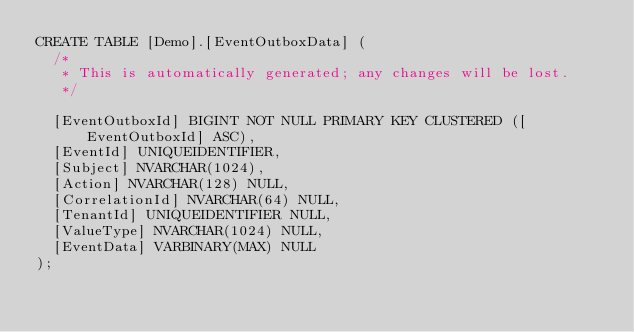<code> <loc_0><loc_0><loc_500><loc_500><_SQL_>CREATE TABLE [Demo].[EventOutboxData] (
  /*
   * This is automatically generated; any changes will be lost.
   */

  [EventOutboxId] BIGINT NOT NULL PRIMARY KEY CLUSTERED ([EventOutboxId] ASC),
  [EventId] UNIQUEIDENTIFIER,
  [Subject] NVARCHAR(1024),
  [Action] NVARCHAR(128) NULL,
  [CorrelationId] NVARCHAR(64) NULL,
  [TenantId] UNIQUEIDENTIFIER NULL,
  [ValueType] NVARCHAR(1024) NULL,
  [EventData] VARBINARY(MAX) NULL
);</code> 